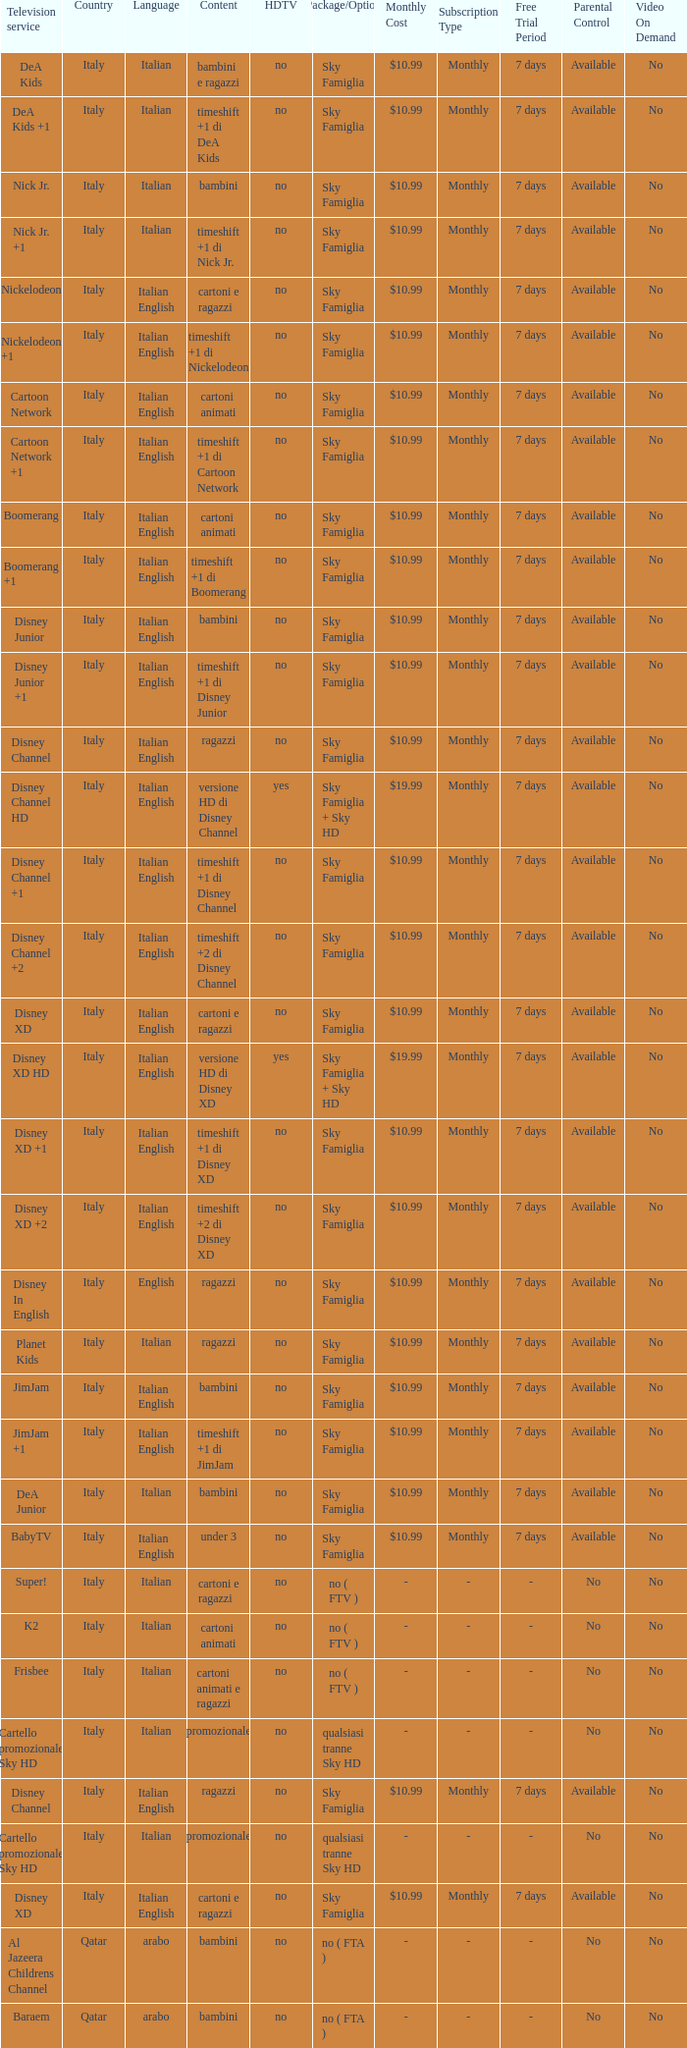What shows as Content for the Television service of nickelodeon +1? Timeshift +1 di nickelodeon. 